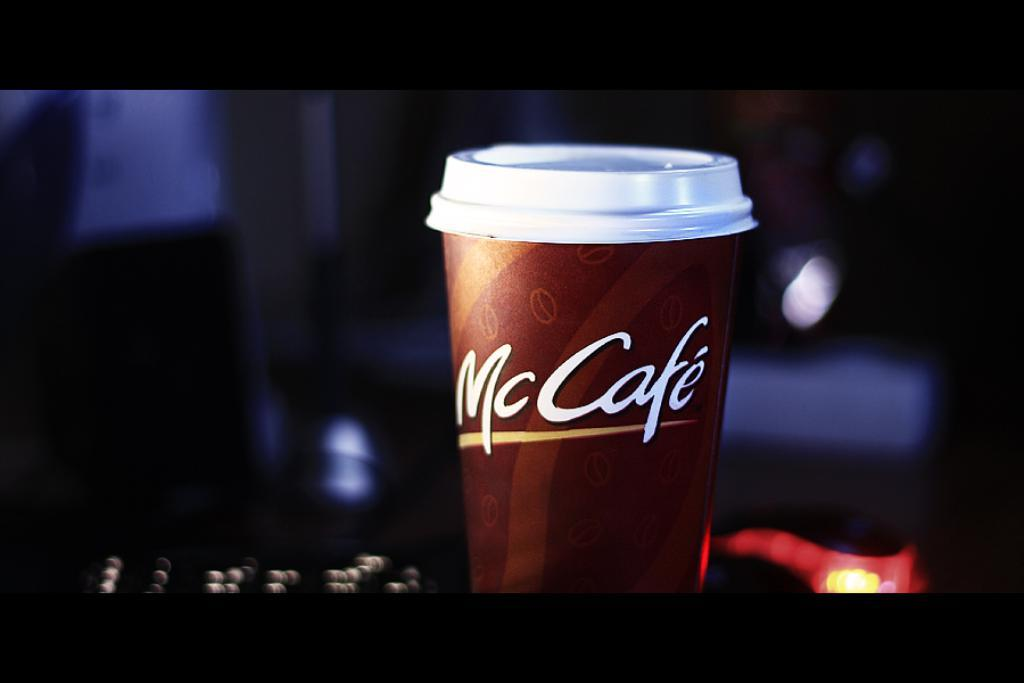<image>
Share a concise interpretation of the image provided. A McCafe coffee cup is sitting in the dark. 